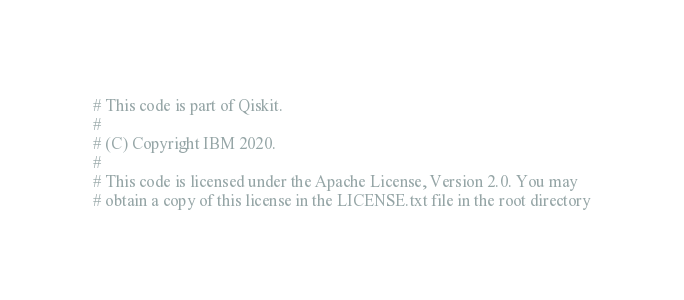Convert code to text. <code><loc_0><loc_0><loc_500><loc_500><_Python_># This code is part of Qiskit.
#
# (C) Copyright IBM 2020.
#
# This code is licensed under the Apache License, Version 2.0. You may
# obtain a copy of this license in the LICENSE.txt file in the root directory</code> 